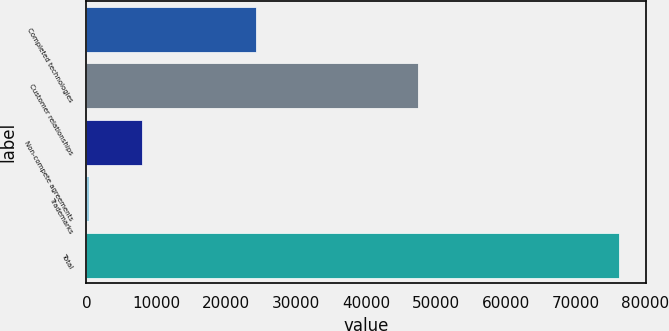<chart> <loc_0><loc_0><loc_500><loc_500><bar_chart><fcel>Completed technologies<fcel>Customer relationships<fcel>Non-compete agreements<fcel>Trademarks<fcel>Total<nl><fcel>24199<fcel>47388<fcel>7892.8<fcel>295<fcel>76273<nl></chart> 